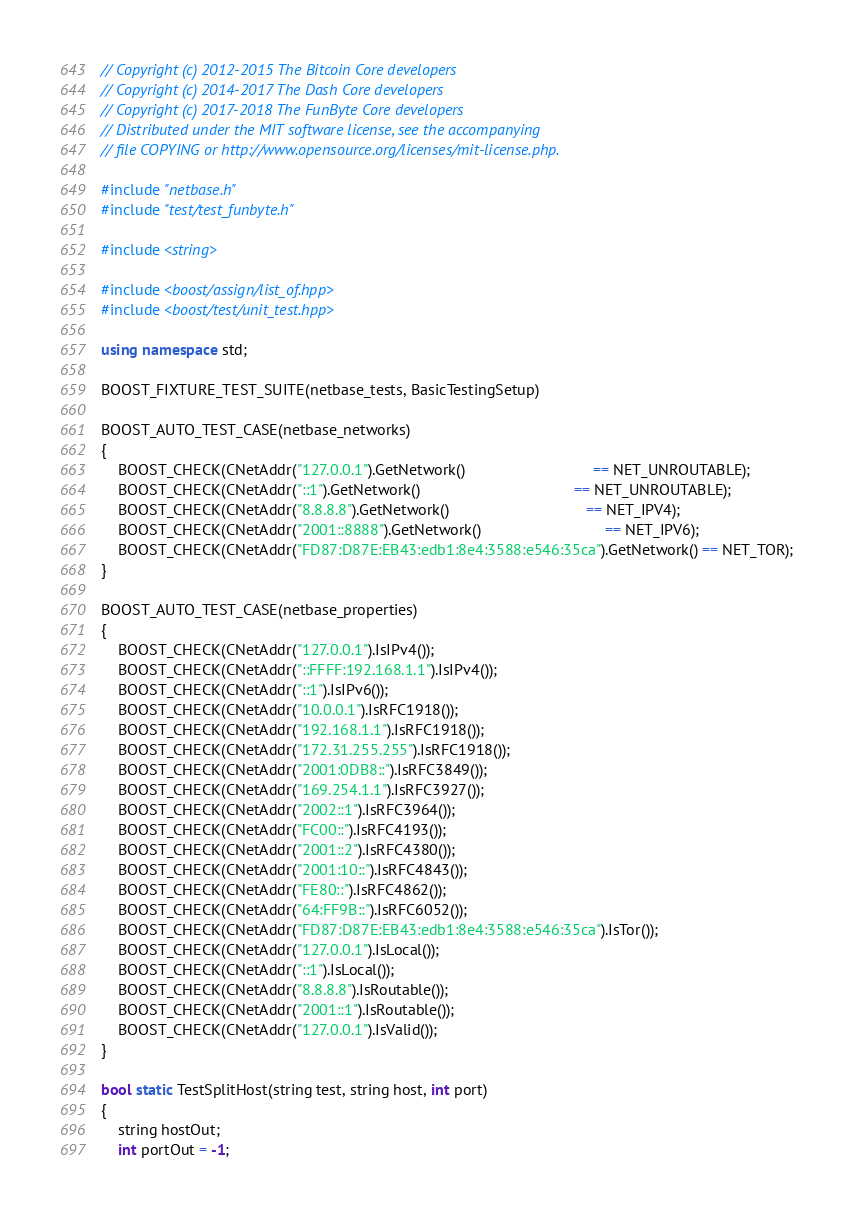Convert code to text. <code><loc_0><loc_0><loc_500><loc_500><_C++_>// Copyright (c) 2012-2015 The Bitcoin Core developers
// Copyright (c) 2014-2017 The Dash Core developers
// Copyright (c) 2017-2018 The FunByte Core developers
// Distributed under the MIT software license, see the accompanying
// file COPYING or http://www.opensource.org/licenses/mit-license.php.

#include "netbase.h"
#include "test/test_funbyte.h"

#include <string>

#include <boost/assign/list_of.hpp>
#include <boost/test/unit_test.hpp>

using namespace std;

BOOST_FIXTURE_TEST_SUITE(netbase_tests, BasicTestingSetup)

BOOST_AUTO_TEST_CASE(netbase_networks)
{
    BOOST_CHECK(CNetAddr("127.0.0.1").GetNetwork()                              == NET_UNROUTABLE);
    BOOST_CHECK(CNetAddr("::1").GetNetwork()                                    == NET_UNROUTABLE);
    BOOST_CHECK(CNetAddr("8.8.8.8").GetNetwork()                                == NET_IPV4);
    BOOST_CHECK(CNetAddr("2001::8888").GetNetwork()                             == NET_IPV6);
    BOOST_CHECK(CNetAddr("FD87:D87E:EB43:edb1:8e4:3588:e546:35ca").GetNetwork() == NET_TOR);
}

BOOST_AUTO_TEST_CASE(netbase_properties)
{
    BOOST_CHECK(CNetAddr("127.0.0.1").IsIPv4());
    BOOST_CHECK(CNetAddr("::FFFF:192.168.1.1").IsIPv4());
    BOOST_CHECK(CNetAddr("::1").IsIPv6());
    BOOST_CHECK(CNetAddr("10.0.0.1").IsRFC1918());
    BOOST_CHECK(CNetAddr("192.168.1.1").IsRFC1918());
    BOOST_CHECK(CNetAddr("172.31.255.255").IsRFC1918());
    BOOST_CHECK(CNetAddr("2001:0DB8::").IsRFC3849());
    BOOST_CHECK(CNetAddr("169.254.1.1").IsRFC3927());
    BOOST_CHECK(CNetAddr("2002::1").IsRFC3964());
    BOOST_CHECK(CNetAddr("FC00::").IsRFC4193());
    BOOST_CHECK(CNetAddr("2001::2").IsRFC4380());
    BOOST_CHECK(CNetAddr("2001:10::").IsRFC4843());
    BOOST_CHECK(CNetAddr("FE80::").IsRFC4862());
    BOOST_CHECK(CNetAddr("64:FF9B::").IsRFC6052());
    BOOST_CHECK(CNetAddr("FD87:D87E:EB43:edb1:8e4:3588:e546:35ca").IsTor());
    BOOST_CHECK(CNetAddr("127.0.0.1").IsLocal());
    BOOST_CHECK(CNetAddr("::1").IsLocal());
    BOOST_CHECK(CNetAddr("8.8.8.8").IsRoutable());
    BOOST_CHECK(CNetAddr("2001::1").IsRoutable());
    BOOST_CHECK(CNetAddr("127.0.0.1").IsValid());
}

bool static TestSplitHost(string test, string host, int port)
{
    string hostOut;
    int portOut = -1;</code> 